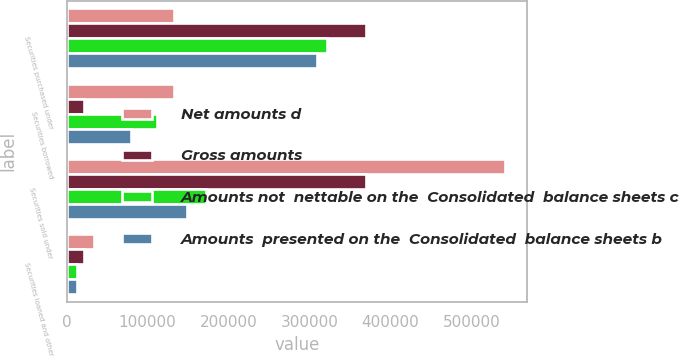Convert chart. <chart><loc_0><loc_0><loc_500><loc_500><stacked_bar_chart><ecel><fcel>Securities purchased under<fcel>Securities borrowed<fcel>Securities sold under<fcel>Securities loaned and other<nl><fcel>Net amounts d<fcel>132955<fcel>132955<fcel>541587<fcel>33700<nl><fcel>Gross amounts<fcel>369612<fcel>20960<fcel>369612<fcel>20960<nl><fcel>Amounts not  nettable on the  Consolidated  balance sheets c<fcel>321504<fcel>111995<fcel>171975<fcel>12740<nl><fcel>Amounts  presented on the  Consolidated  balance sheets b<fcel>308854<fcel>79747<fcel>149125<fcel>12358<nl></chart> 